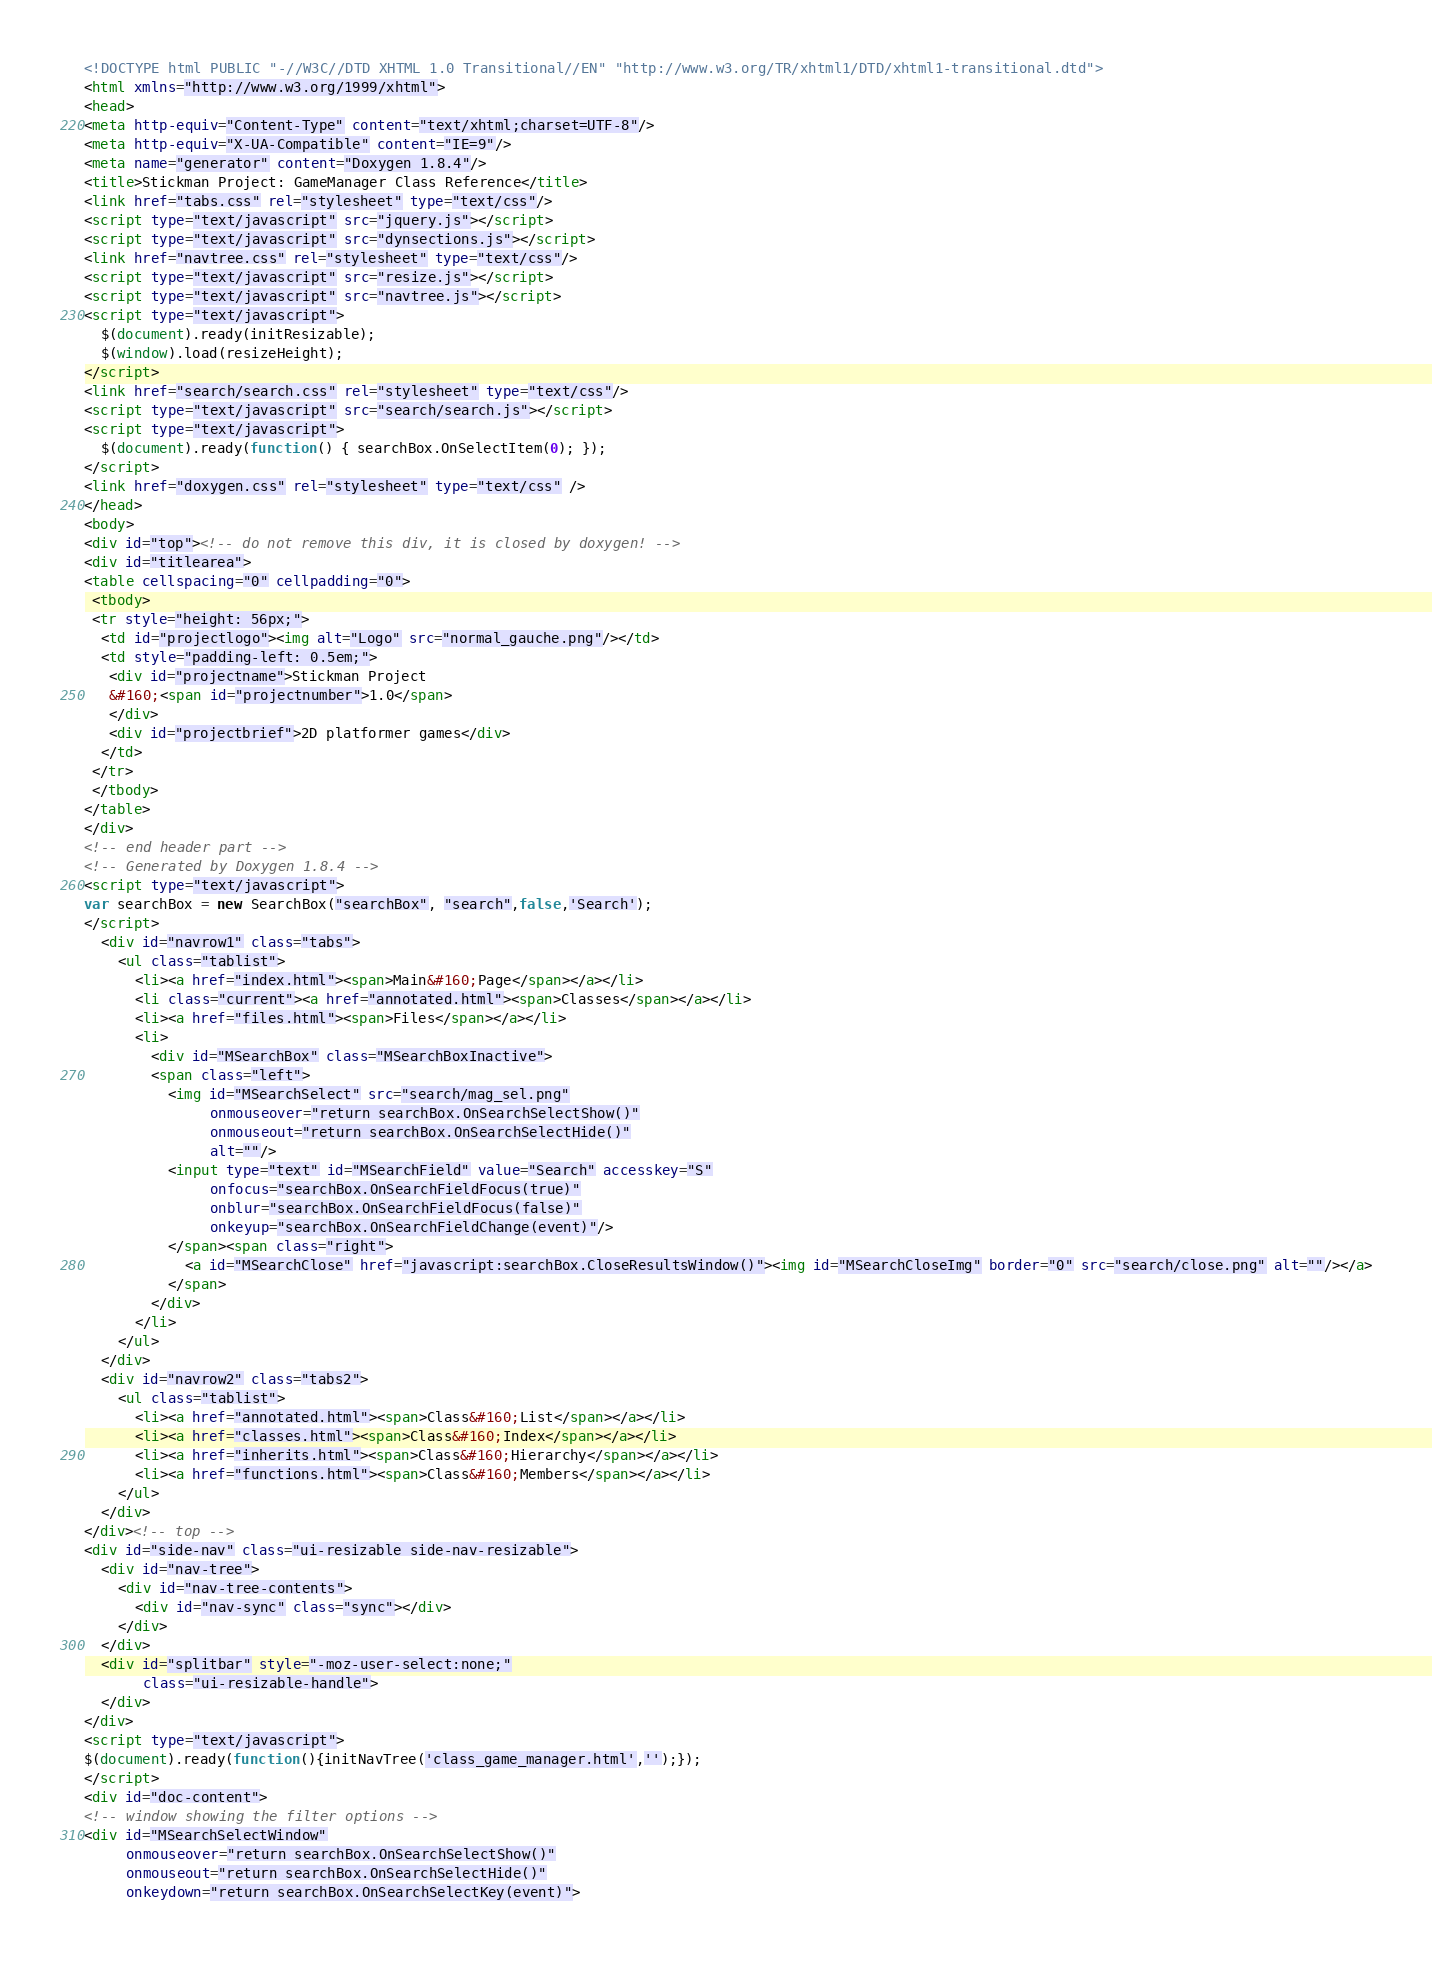<code> <loc_0><loc_0><loc_500><loc_500><_HTML_><!DOCTYPE html PUBLIC "-//W3C//DTD XHTML 1.0 Transitional//EN" "http://www.w3.org/TR/xhtml1/DTD/xhtml1-transitional.dtd">
<html xmlns="http://www.w3.org/1999/xhtml">
<head>
<meta http-equiv="Content-Type" content="text/xhtml;charset=UTF-8"/>
<meta http-equiv="X-UA-Compatible" content="IE=9"/>
<meta name="generator" content="Doxygen 1.8.4"/>
<title>Stickman Project: GameManager Class Reference</title>
<link href="tabs.css" rel="stylesheet" type="text/css"/>
<script type="text/javascript" src="jquery.js"></script>
<script type="text/javascript" src="dynsections.js"></script>
<link href="navtree.css" rel="stylesheet" type="text/css"/>
<script type="text/javascript" src="resize.js"></script>
<script type="text/javascript" src="navtree.js"></script>
<script type="text/javascript">
  $(document).ready(initResizable);
  $(window).load(resizeHeight);
</script>
<link href="search/search.css" rel="stylesheet" type="text/css"/>
<script type="text/javascript" src="search/search.js"></script>
<script type="text/javascript">
  $(document).ready(function() { searchBox.OnSelectItem(0); });
</script>
<link href="doxygen.css" rel="stylesheet" type="text/css" />
</head>
<body>
<div id="top"><!-- do not remove this div, it is closed by doxygen! -->
<div id="titlearea">
<table cellspacing="0" cellpadding="0">
 <tbody>
 <tr style="height: 56px;">
  <td id="projectlogo"><img alt="Logo" src="normal_gauche.png"/></td>
  <td style="padding-left: 0.5em;">
   <div id="projectname">Stickman Project
   &#160;<span id="projectnumber">1.0</span>
   </div>
   <div id="projectbrief">2D platformer games</div>
  </td>
 </tr>
 </tbody>
</table>
</div>
<!-- end header part -->
<!-- Generated by Doxygen 1.8.4 -->
<script type="text/javascript">
var searchBox = new SearchBox("searchBox", "search",false,'Search');
</script>
  <div id="navrow1" class="tabs">
    <ul class="tablist">
      <li><a href="index.html"><span>Main&#160;Page</span></a></li>
      <li class="current"><a href="annotated.html"><span>Classes</span></a></li>
      <li><a href="files.html"><span>Files</span></a></li>
      <li>
        <div id="MSearchBox" class="MSearchBoxInactive">
        <span class="left">
          <img id="MSearchSelect" src="search/mag_sel.png"
               onmouseover="return searchBox.OnSearchSelectShow()"
               onmouseout="return searchBox.OnSearchSelectHide()"
               alt=""/>
          <input type="text" id="MSearchField" value="Search" accesskey="S"
               onfocus="searchBox.OnSearchFieldFocus(true)" 
               onblur="searchBox.OnSearchFieldFocus(false)" 
               onkeyup="searchBox.OnSearchFieldChange(event)"/>
          </span><span class="right">
            <a id="MSearchClose" href="javascript:searchBox.CloseResultsWindow()"><img id="MSearchCloseImg" border="0" src="search/close.png" alt=""/></a>
          </span>
        </div>
      </li>
    </ul>
  </div>
  <div id="navrow2" class="tabs2">
    <ul class="tablist">
      <li><a href="annotated.html"><span>Class&#160;List</span></a></li>
      <li><a href="classes.html"><span>Class&#160;Index</span></a></li>
      <li><a href="inherits.html"><span>Class&#160;Hierarchy</span></a></li>
      <li><a href="functions.html"><span>Class&#160;Members</span></a></li>
    </ul>
  </div>
</div><!-- top -->
<div id="side-nav" class="ui-resizable side-nav-resizable">
  <div id="nav-tree">
    <div id="nav-tree-contents">
      <div id="nav-sync" class="sync"></div>
    </div>
  </div>
  <div id="splitbar" style="-moz-user-select:none;" 
       class="ui-resizable-handle">
  </div>
</div>
<script type="text/javascript">
$(document).ready(function(){initNavTree('class_game_manager.html','');});
</script>
<div id="doc-content">
<!-- window showing the filter options -->
<div id="MSearchSelectWindow"
     onmouseover="return searchBox.OnSearchSelectShow()"
     onmouseout="return searchBox.OnSearchSelectHide()"
     onkeydown="return searchBox.OnSearchSelectKey(event)"></code> 